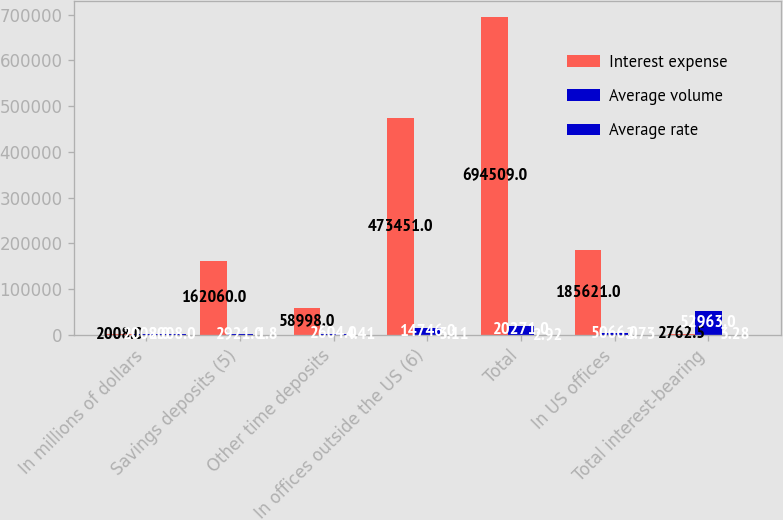Convert chart. <chart><loc_0><loc_0><loc_500><loc_500><stacked_bar_chart><ecel><fcel>In millions of dollars<fcel>Savings deposits (5)<fcel>Other time deposits<fcel>In offices outside the US (6)<fcel>Total<fcel>In US offices<fcel>Total interest-bearing<nl><fcel>Interest expense<fcel>2008<fcel>162060<fcel>58998<fcel>473451<fcel>694509<fcel>185621<fcel>2762.5<nl><fcel>Average volume<fcel>2008<fcel>2921<fcel>2604<fcel>14746<fcel>20271<fcel>5066<fcel>52963<nl><fcel>Average rate<fcel>2008<fcel>1.8<fcel>4.41<fcel>3.11<fcel>2.92<fcel>2.73<fcel>3.28<nl></chart> 